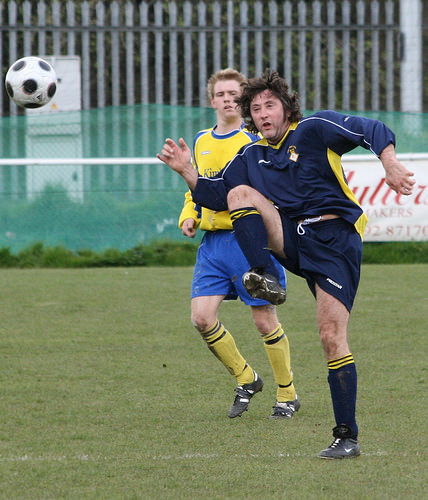<image>
Is the ball next to the man? No. The ball is not positioned next to the man. They are located in different areas of the scene. Is there a ball in front of the man? Yes. The ball is positioned in front of the man, appearing closer to the camera viewpoint. 